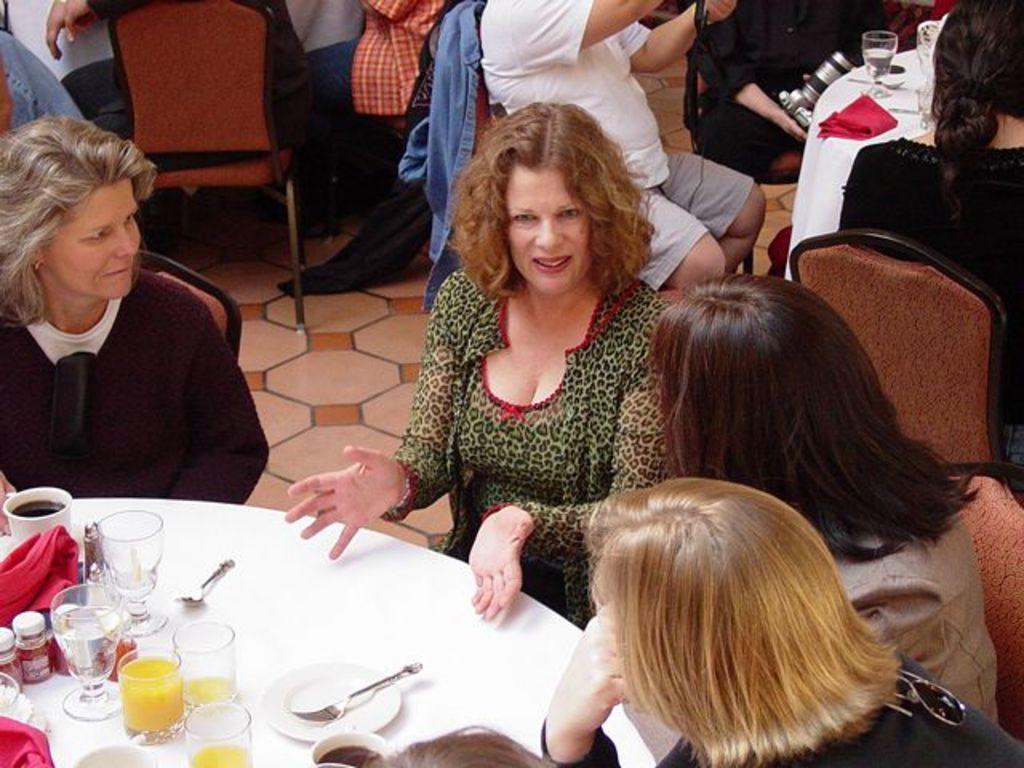How would you summarize this image in a sentence or two? In this image we can see many people sitting on chairs. There are tables. On the table there are glasses, napkins, bottles, spoon, fork, plate and some other items. And there is a person holding a camera. 